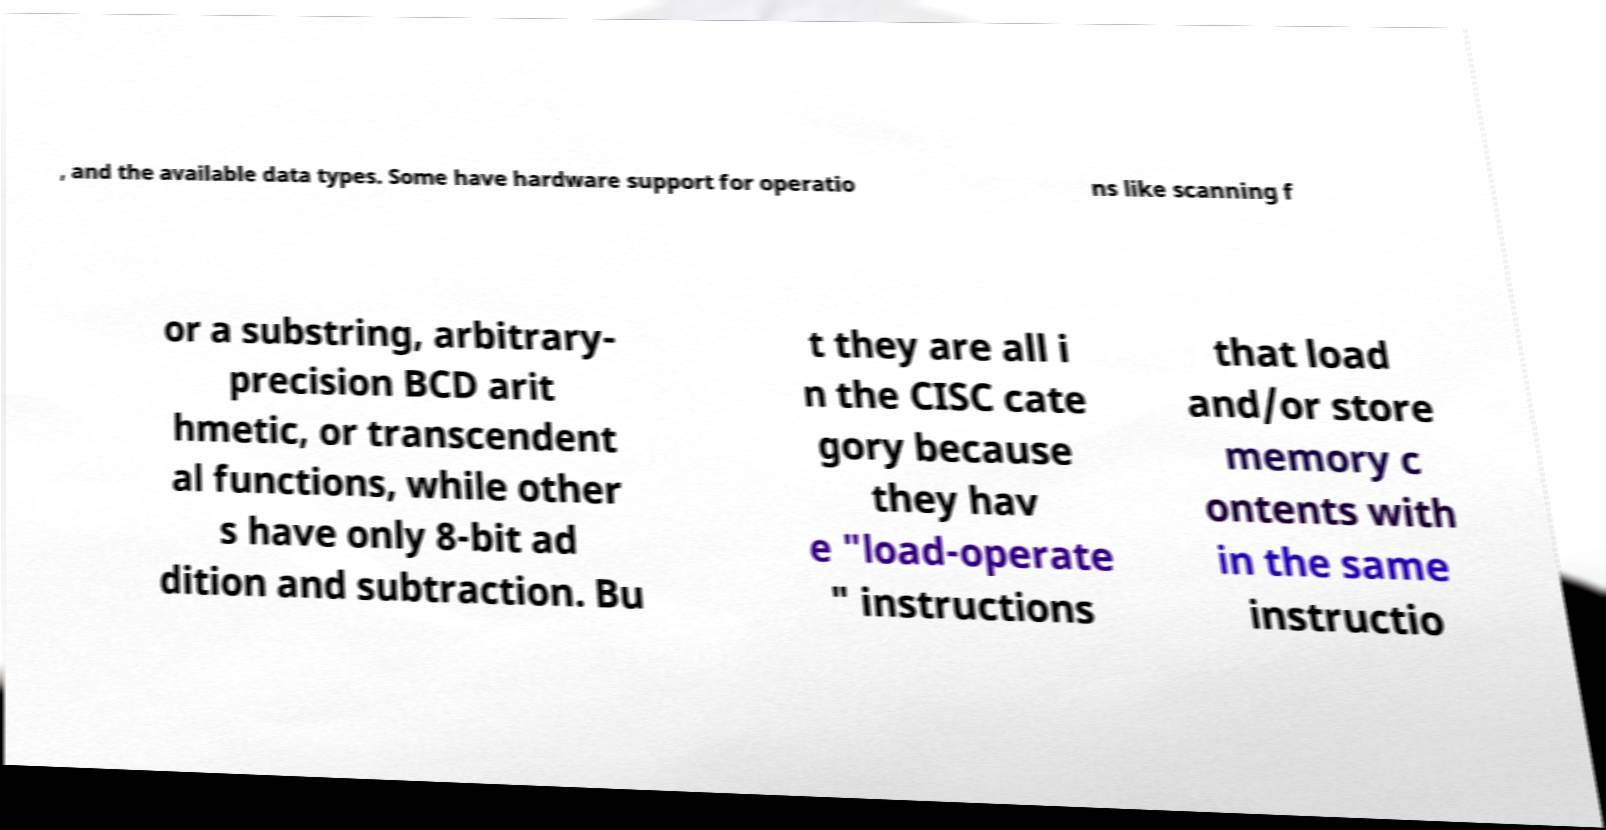What messages or text are displayed in this image? I need them in a readable, typed format. , and the available data types. Some have hardware support for operatio ns like scanning f or a substring, arbitrary- precision BCD arit hmetic, or transcendent al functions, while other s have only 8-bit ad dition and subtraction. Bu t they are all i n the CISC cate gory because they hav e "load-operate " instructions that load and/or store memory c ontents with in the same instructio 